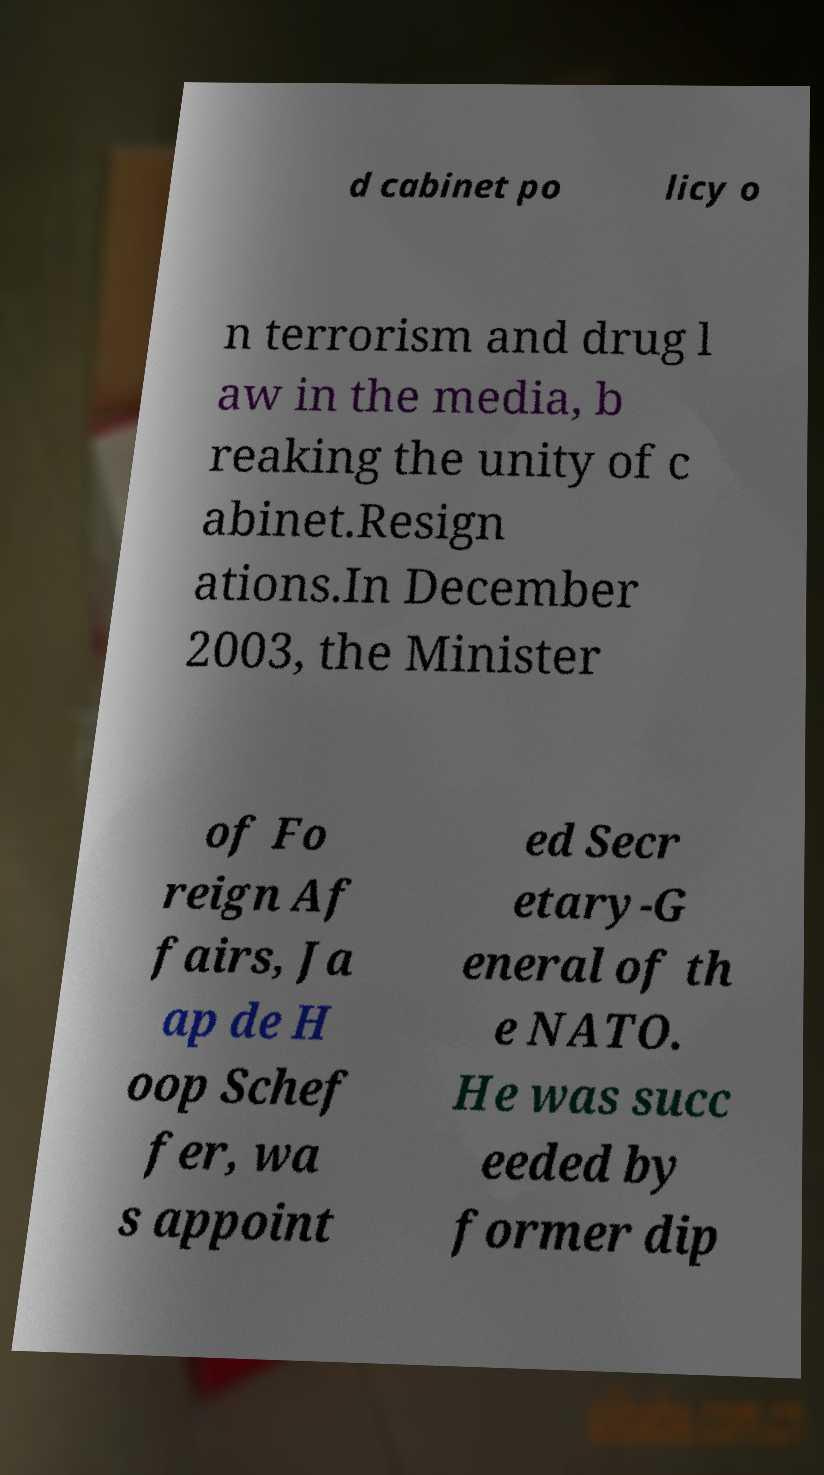Can you read and provide the text displayed in the image?This photo seems to have some interesting text. Can you extract and type it out for me? d cabinet po licy o n terrorism and drug l aw in the media, b reaking the unity of c abinet.Resign ations.In December 2003, the Minister of Fo reign Af fairs, Ja ap de H oop Schef fer, wa s appoint ed Secr etary-G eneral of th e NATO. He was succ eeded by former dip 